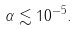Convert formula to latex. <formula><loc_0><loc_0><loc_500><loc_500>\alpha \lesssim 1 0 ^ { - 5 } .</formula> 